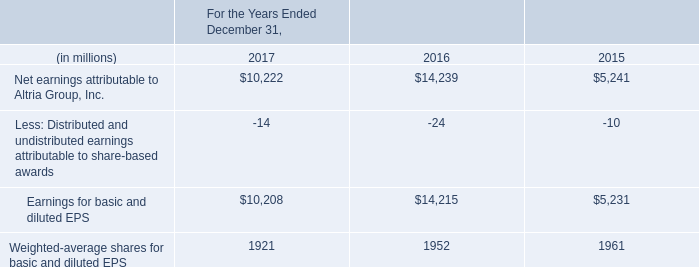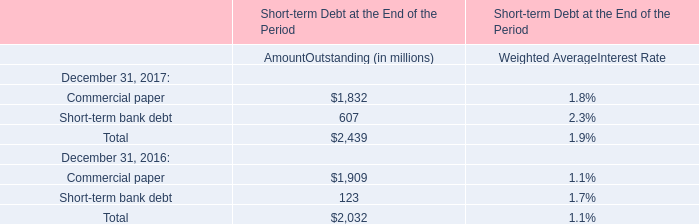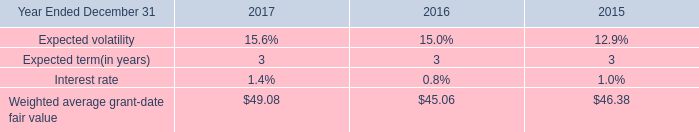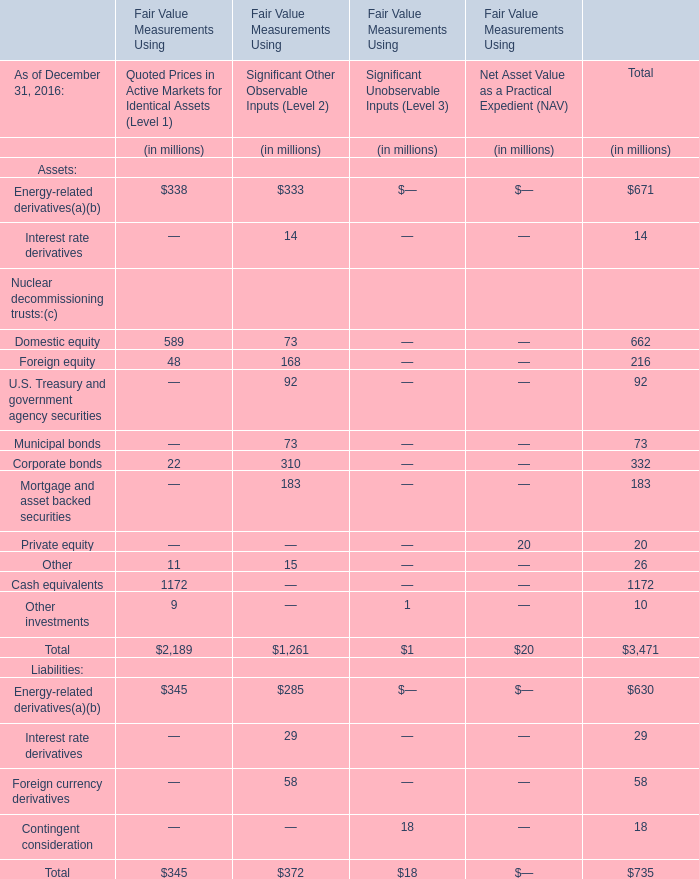What's the average of the Weighted average grant-date fair value in the years where Commercial paper for AmountOutstanding (in millions) is positive? 
Computations: ((49.08 + 45.06) / 2)
Answer: 47.07. 